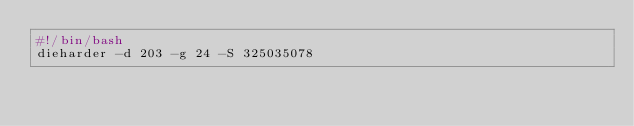<code> <loc_0><loc_0><loc_500><loc_500><_Bash_>#!/bin/bash
dieharder -d 203 -g 24 -S 325035078
</code> 